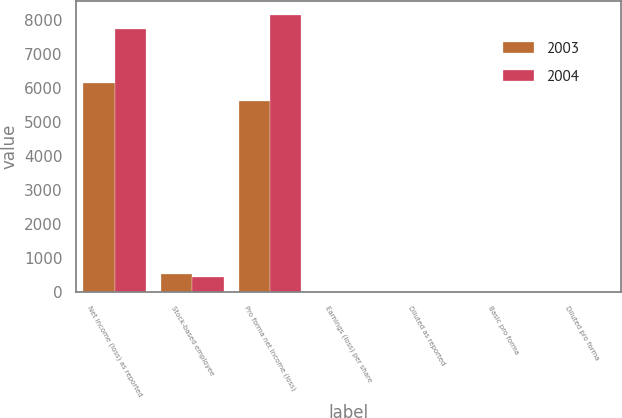<chart> <loc_0><loc_0><loc_500><loc_500><stacked_bar_chart><ecel><fcel>Net income (loss) as reported<fcel>Stock-based employee<fcel>Pro forma net income (loss)<fcel>Earnings (loss) per share<fcel>Diluted as reported<fcel>Basic pro forma<fcel>Diluted pro forma<nl><fcel>2003<fcel>6126<fcel>527<fcel>5599<fcel>0.24<fcel>0.24<fcel>0.22<fcel>0.22<nl><fcel>2004<fcel>7714<fcel>434<fcel>8148<fcel>0.34<fcel>0.34<fcel>0.36<fcel>0.36<nl></chart> 